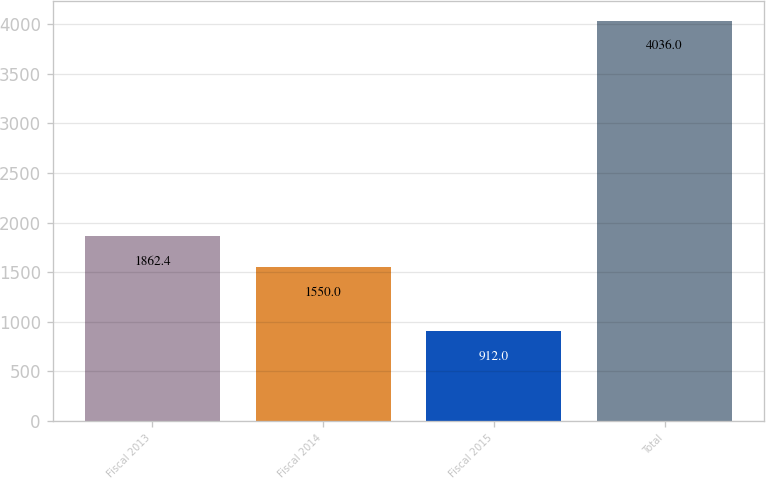<chart> <loc_0><loc_0><loc_500><loc_500><bar_chart><fcel>Fiscal 2013<fcel>Fiscal 2014<fcel>Fiscal 2015<fcel>Total<nl><fcel>1862.4<fcel>1550<fcel>912<fcel>4036<nl></chart> 